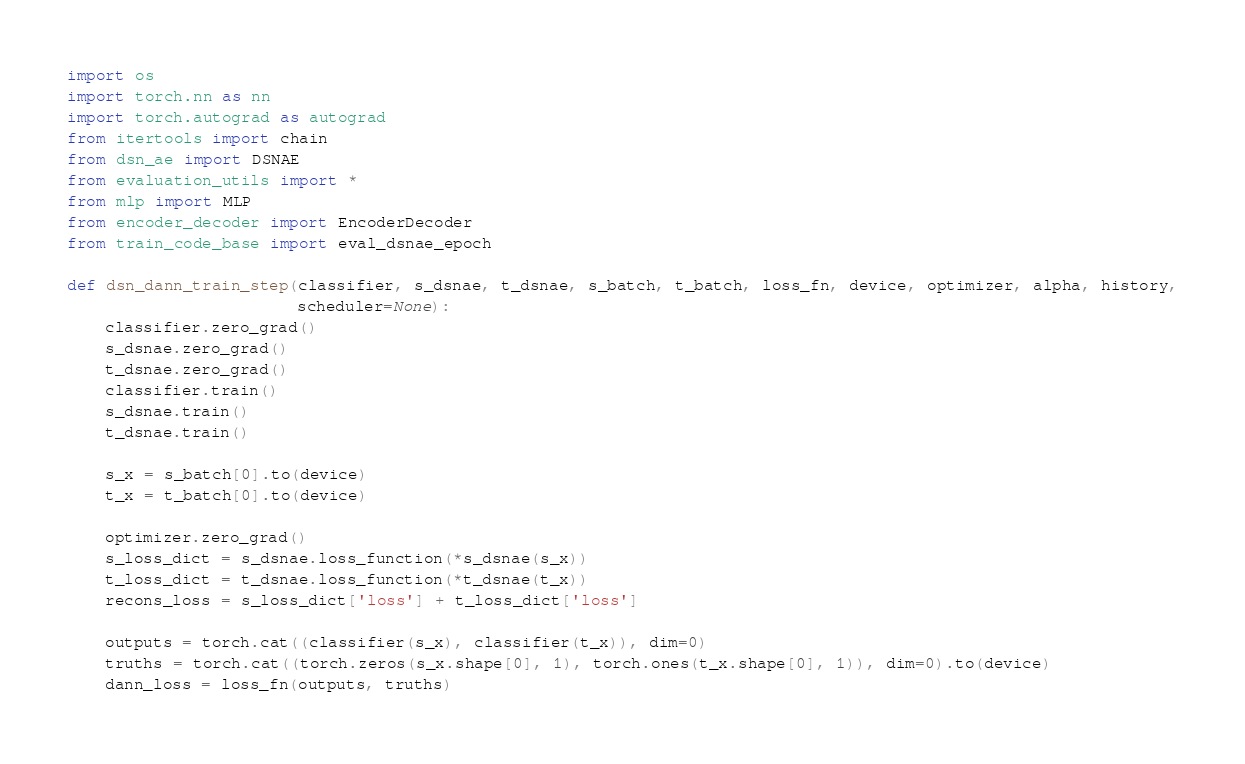Convert code to text. <code><loc_0><loc_0><loc_500><loc_500><_Python_>import os
import torch.nn as nn
import torch.autograd as autograd
from itertools import chain
from dsn_ae import DSNAE
from evaluation_utils import *
from mlp import MLP
from encoder_decoder import EncoderDecoder
from train_code_base import eval_dsnae_epoch

def dsn_dann_train_step(classifier, s_dsnae, t_dsnae, s_batch, t_batch, loss_fn, device, optimizer, alpha, history,
                        scheduler=None):
    classifier.zero_grad()
    s_dsnae.zero_grad()
    t_dsnae.zero_grad()
    classifier.train()
    s_dsnae.train()
    t_dsnae.train()

    s_x = s_batch[0].to(device)
    t_x = t_batch[0].to(device)

    optimizer.zero_grad()
    s_loss_dict = s_dsnae.loss_function(*s_dsnae(s_x))
    t_loss_dict = t_dsnae.loss_function(*t_dsnae(t_x))
    recons_loss = s_loss_dict['loss'] + t_loss_dict['loss']

    outputs = torch.cat((classifier(s_x), classifier(t_x)), dim=0)
    truths = torch.cat((torch.zeros(s_x.shape[0], 1), torch.ones(t_x.shape[0], 1)), dim=0).to(device)
    dann_loss = loss_fn(outputs, truths)
</code> 